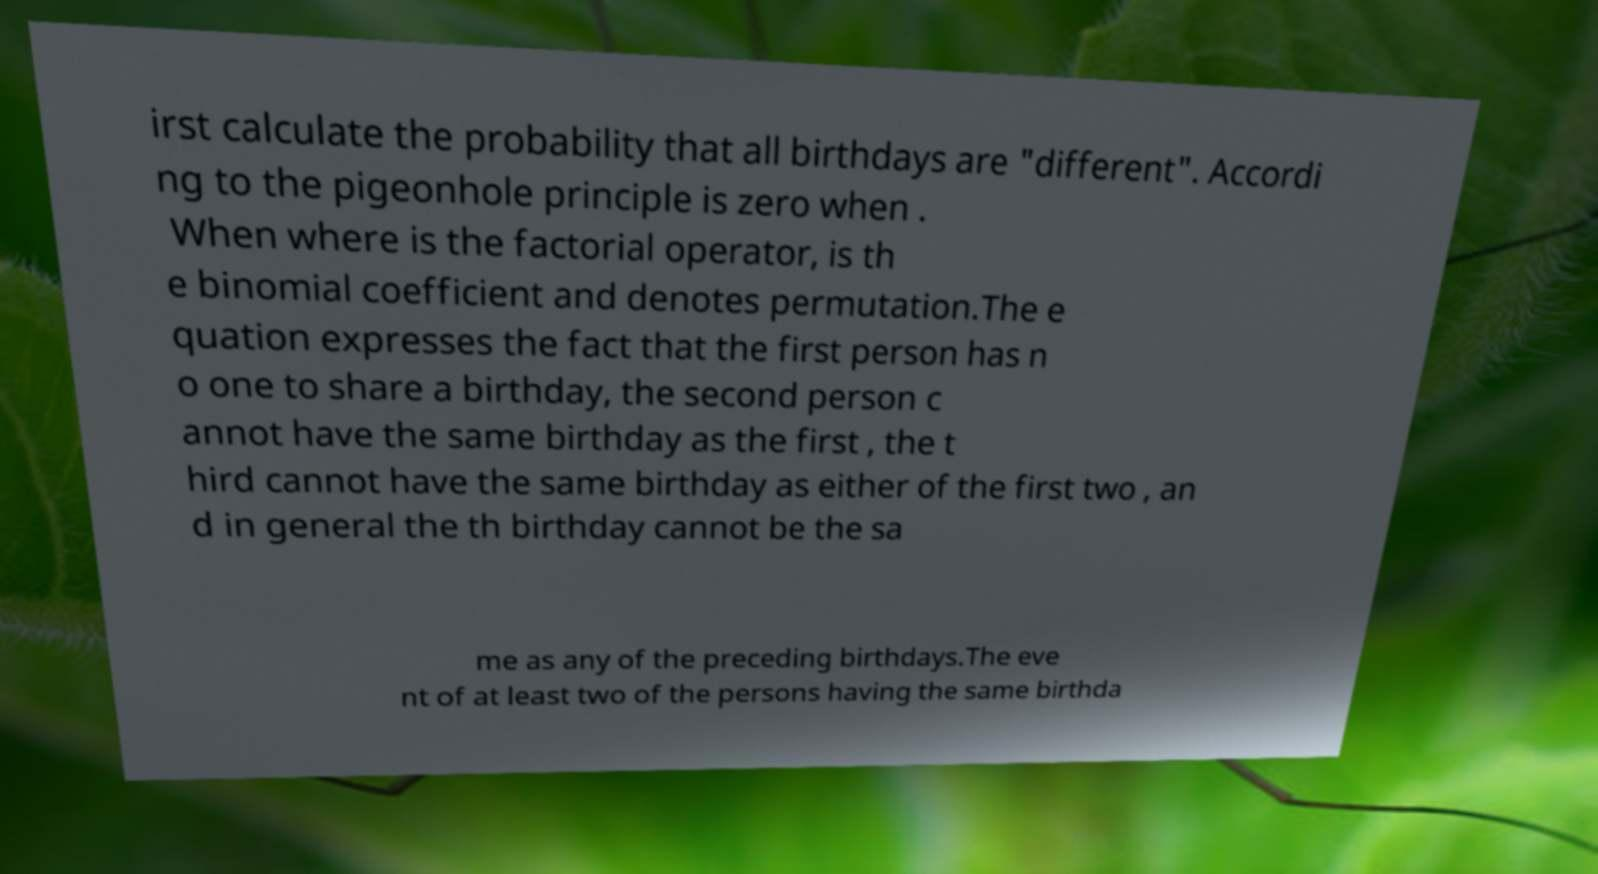I need the written content from this picture converted into text. Can you do that? irst calculate the probability that all birthdays are "different". Accordi ng to the pigeonhole principle is zero when . When where is the factorial operator, is th e binomial coefficient and denotes permutation.The e quation expresses the fact that the first person has n o one to share a birthday, the second person c annot have the same birthday as the first , the t hird cannot have the same birthday as either of the first two , an d in general the th birthday cannot be the sa me as any of the preceding birthdays.The eve nt of at least two of the persons having the same birthda 